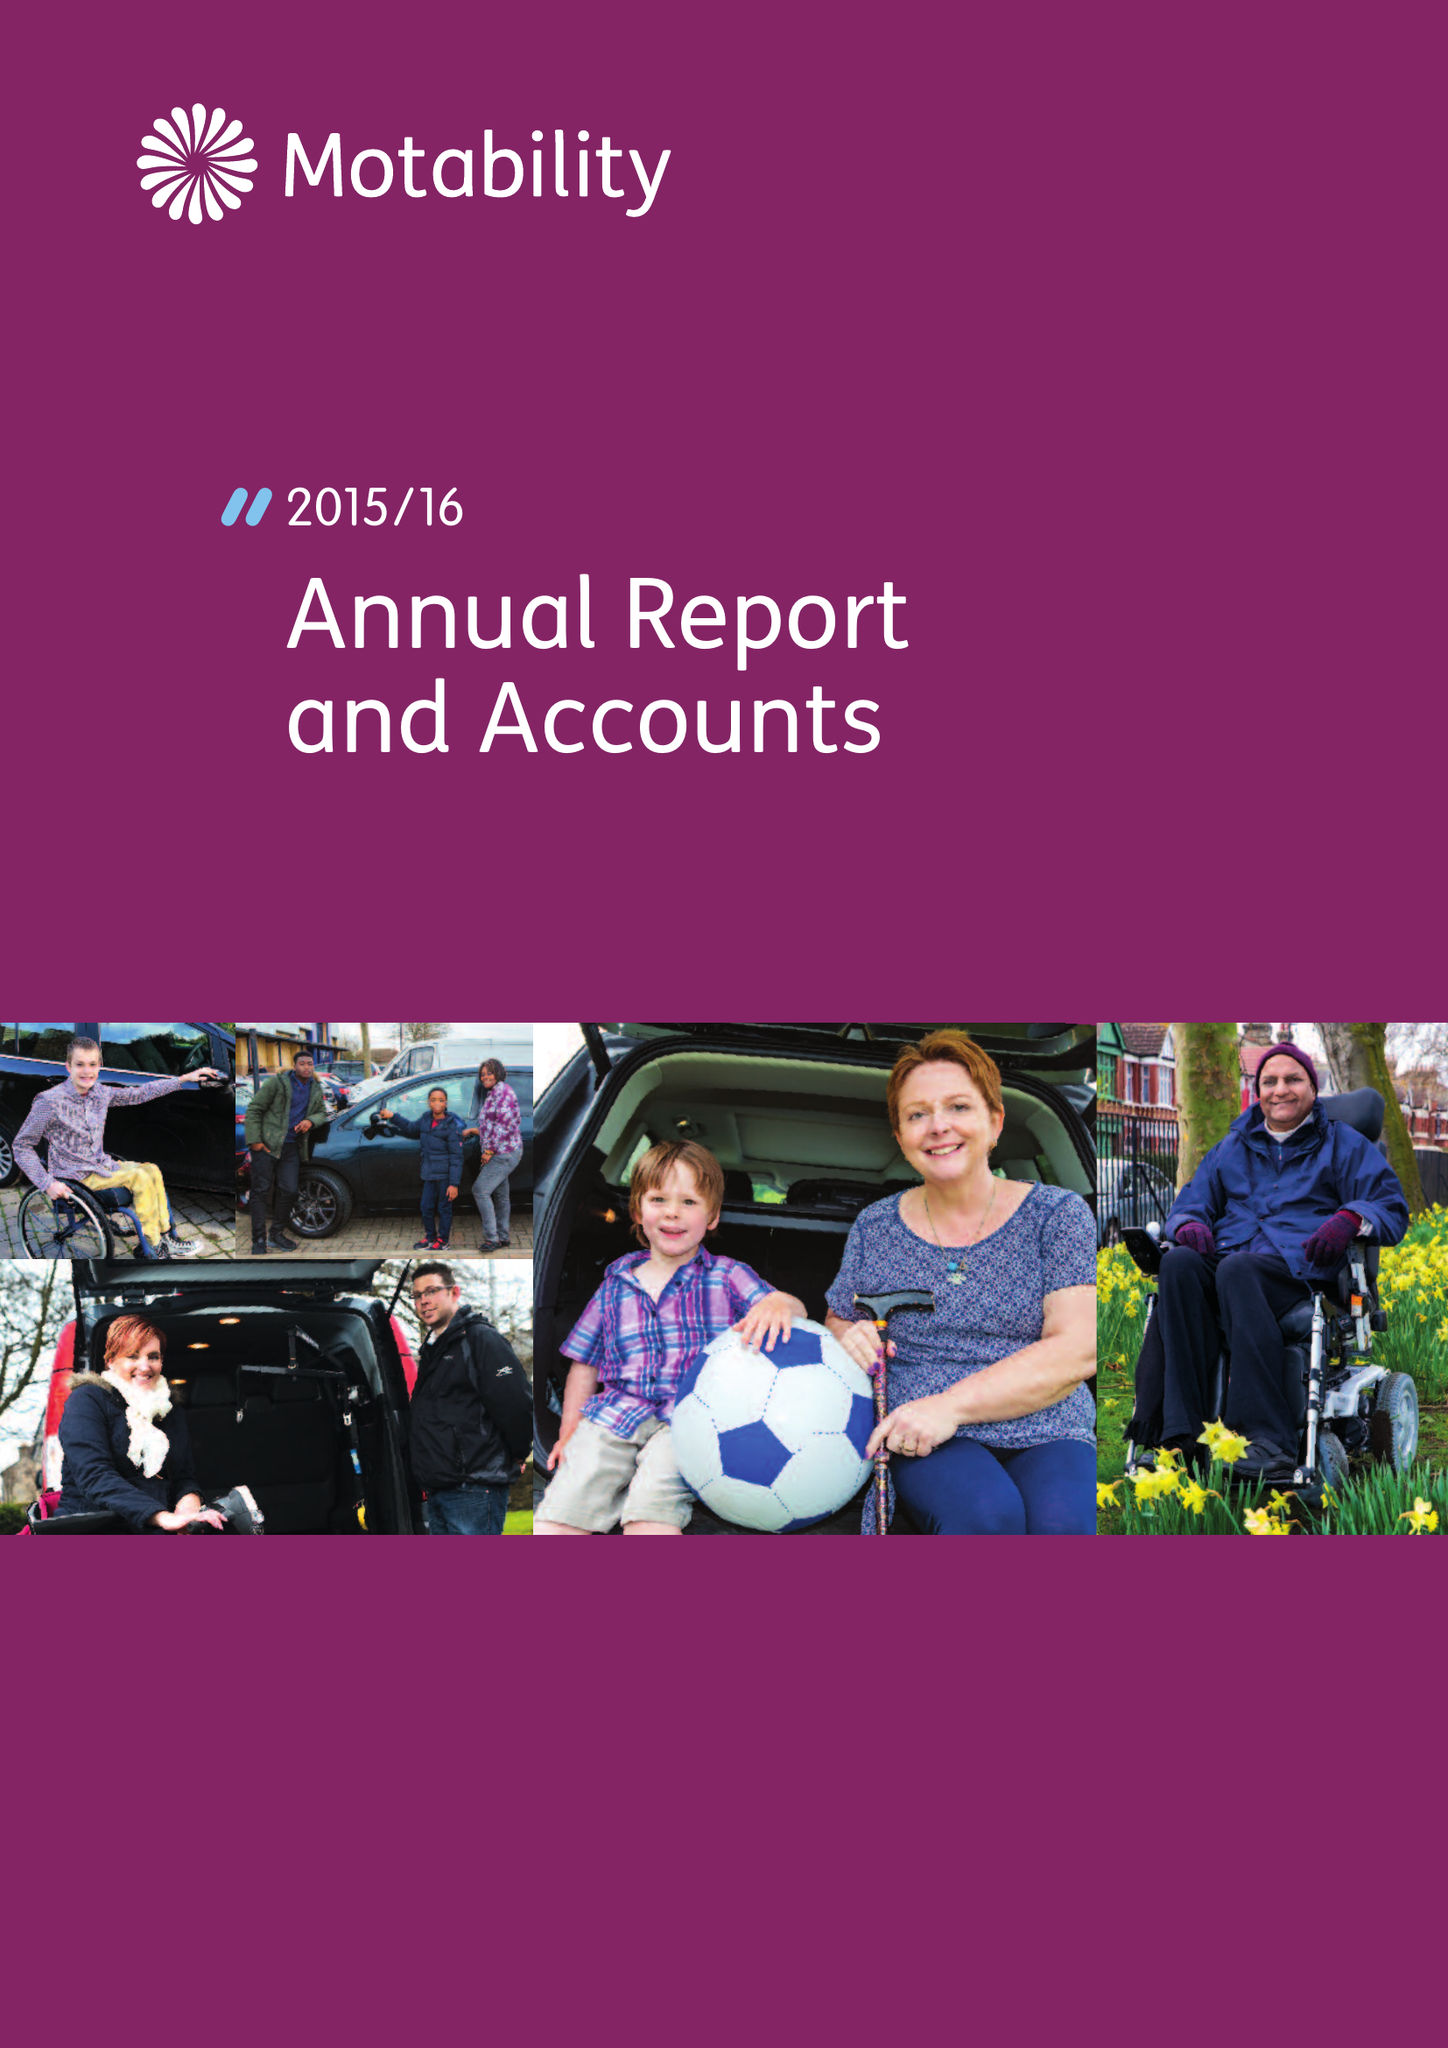What is the value for the address__postcode?
Answer the question using a single word or phrase. CM19 5PX 